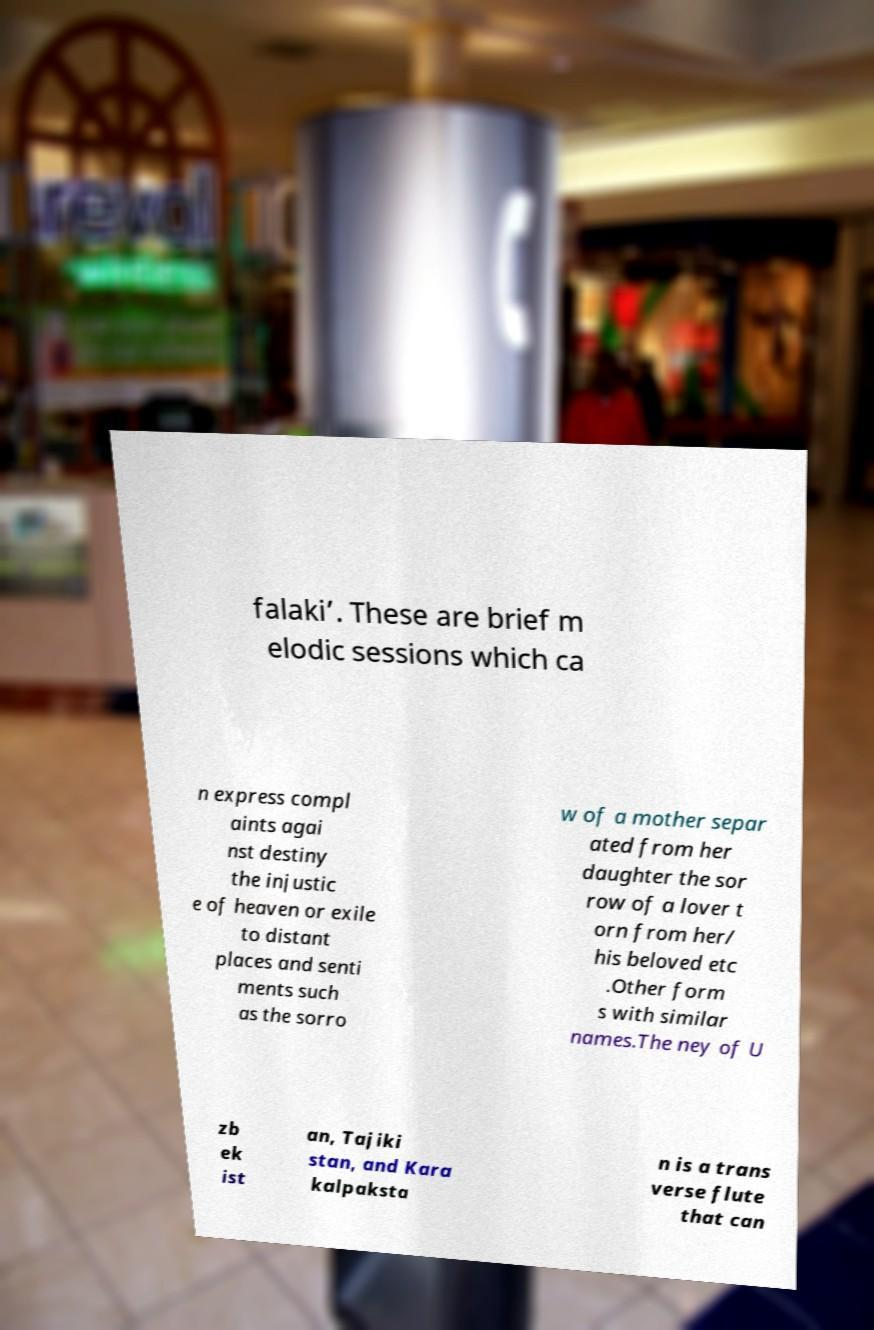Please identify and transcribe the text found in this image. falaki’. These are brief m elodic sessions which ca n express compl aints agai nst destiny the injustic e of heaven or exile to distant places and senti ments such as the sorro w of a mother separ ated from her daughter the sor row of a lover t orn from her/ his beloved etc .Other form s with similar names.The ney of U zb ek ist an, Tajiki stan, and Kara kalpaksta n is a trans verse flute that can 